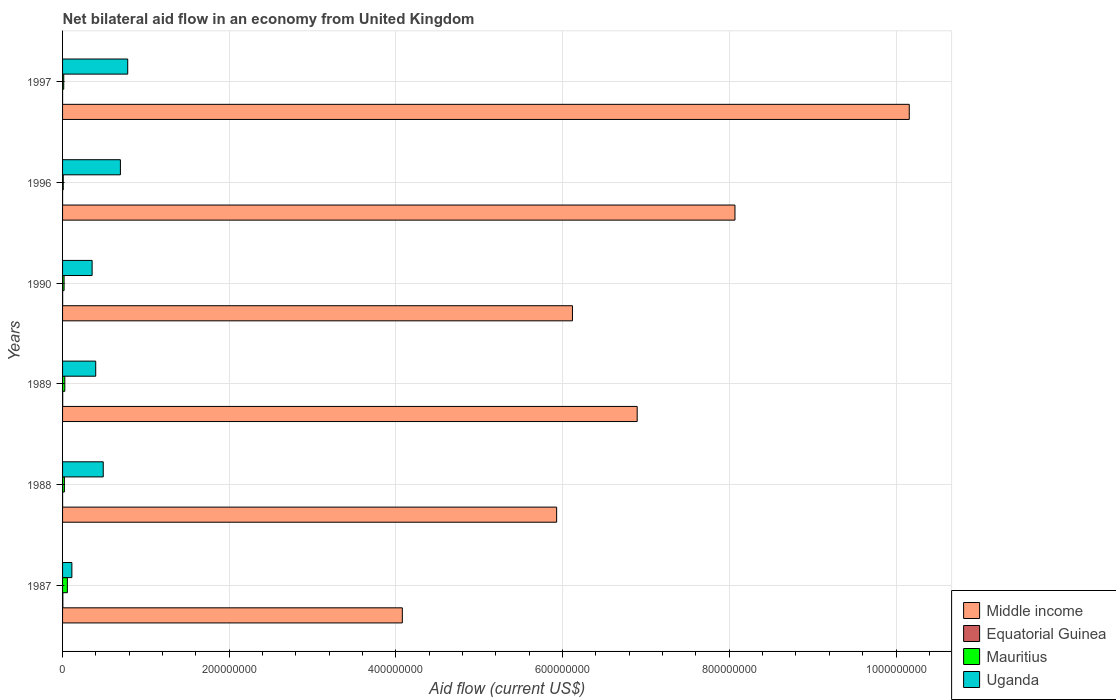How many different coloured bars are there?
Offer a terse response. 4. Are the number of bars per tick equal to the number of legend labels?
Your answer should be very brief. Yes. How many bars are there on the 1st tick from the top?
Keep it short and to the point. 4. How many bars are there on the 6th tick from the bottom?
Ensure brevity in your answer.  4. What is the label of the 6th group of bars from the top?
Ensure brevity in your answer.  1987. What is the net bilateral aid flow in Uganda in 1997?
Make the answer very short. 7.82e+07. Across all years, what is the maximum net bilateral aid flow in Equatorial Guinea?
Provide a succinct answer. 3.40e+05. Across all years, what is the minimum net bilateral aid flow in Equatorial Guinea?
Your answer should be very brief. 10000. In which year was the net bilateral aid flow in Equatorial Guinea minimum?
Your answer should be compact. 1997. What is the total net bilateral aid flow in Equatorial Guinea in the graph?
Offer a terse response. 6.30e+05. What is the difference between the net bilateral aid flow in Uganda in 1988 and that in 1997?
Provide a succinct answer. -2.94e+07. What is the difference between the net bilateral aid flow in Middle income in 1990 and the net bilateral aid flow in Mauritius in 1997?
Offer a terse response. 6.10e+08. What is the average net bilateral aid flow in Equatorial Guinea per year?
Your answer should be very brief. 1.05e+05. In the year 1996, what is the difference between the net bilateral aid flow in Uganda and net bilateral aid flow in Mauritius?
Offer a very short reply. 6.86e+07. In how many years, is the net bilateral aid flow in Uganda greater than 200000000 US$?
Your answer should be very brief. 0. What is the ratio of the net bilateral aid flow in Equatorial Guinea in 1987 to that in 1988?
Make the answer very short. 11.33. Is the difference between the net bilateral aid flow in Uganda in 1987 and 1996 greater than the difference between the net bilateral aid flow in Mauritius in 1987 and 1996?
Offer a very short reply. No. What is the difference between the highest and the lowest net bilateral aid flow in Uganda?
Offer a very short reply. 6.70e+07. In how many years, is the net bilateral aid flow in Mauritius greater than the average net bilateral aid flow in Mauritius taken over all years?
Give a very brief answer. 2. Is the sum of the net bilateral aid flow in Middle income in 1988 and 1997 greater than the maximum net bilateral aid flow in Mauritius across all years?
Ensure brevity in your answer.  Yes. Is it the case that in every year, the sum of the net bilateral aid flow in Equatorial Guinea and net bilateral aid flow in Uganda is greater than the sum of net bilateral aid flow in Middle income and net bilateral aid flow in Mauritius?
Provide a short and direct response. Yes. What does the 4th bar from the top in 1988 represents?
Provide a succinct answer. Middle income. What does the 3rd bar from the bottom in 1987 represents?
Offer a terse response. Mauritius. Is it the case that in every year, the sum of the net bilateral aid flow in Equatorial Guinea and net bilateral aid flow in Mauritius is greater than the net bilateral aid flow in Middle income?
Ensure brevity in your answer.  No. How many bars are there?
Make the answer very short. 24. Does the graph contain any zero values?
Provide a short and direct response. No. Does the graph contain grids?
Provide a succinct answer. Yes. Where does the legend appear in the graph?
Provide a short and direct response. Bottom right. How are the legend labels stacked?
Keep it short and to the point. Vertical. What is the title of the graph?
Keep it short and to the point. Net bilateral aid flow in an economy from United Kingdom. Does "Mauritius" appear as one of the legend labels in the graph?
Give a very brief answer. Yes. What is the label or title of the X-axis?
Make the answer very short. Aid flow (current US$). What is the label or title of the Y-axis?
Ensure brevity in your answer.  Years. What is the Aid flow (current US$) of Middle income in 1987?
Provide a succinct answer. 4.08e+08. What is the Aid flow (current US$) of Equatorial Guinea in 1987?
Keep it short and to the point. 3.40e+05. What is the Aid flow (current US$) of Mauritius in 1987?
Offer a very short reply. 5.77e+06. What is the Aid flow (current US$) of Uganda in 1987?
Your answer should be very brief. 1.12e+07. What is the Aid flow (current US$) of Middle income in 1988?
Offer a very short reply. 5.93e+08. What is the Aid flow (current US$) of Mauritius in 1988?
Make the answer very short. 2.18e+06. What is the Aid flow (current US$) in Uganda in 1988?
Ensure brevity in your answer.  4.88e+07. What is the Aid flow (current US$) of Middle income in 1989?
Ensure brevity in your answer.  6.89e+08. What is the Aid flow (current US$) of Equatorial Guinea in 1989?
Offer a terse response. 1.40e+05. What is the Aid flow (current US$) of Mauritius in 1989?
Keep it short and to the point. 2.70e+06. What is the Aid flow (current US$) of Uganda in 1989?
Your response must be concise. 3.98e+07. What is the Aid flow (current US$) in Middle income in 1990?
Your answer should be very brief. 6.12e+08. What is the Aid flow (current US$) in Equatorial Guinea in 1990?
Ensure brevity in your answer.  9.00e+04. What is the Aid flow (current US$) of Mauritius in 1990?
Offer a terse response. 1.82e+06. What is the Aid flow (current US$) of Uganda in 1990?
Keep it short and to the point. 3.54e+07. What is the Aid flow (current US$) of Middle income in 1996?
Ensure brevity in your answer.  8.07e+08. What is the Aid flow (current US$) in Equatorial Guinea in 1996?
Provide a short and direct response. 2.00e+04. What is the Aid flow (current US$) of Mauritius in 1996?
Your response must be concise. 8.30e+05. What is the Aid flow (current US$) of Uganda in 1996?
Keep it short and to the point. 6.94e+07. What is the Aid flow (current US$) of Middle income in 1997?
Your answer should be compact. 1.02e+09. What is the Aid flow (current US$) in Mauritius in 1997?
Offer a very short reply. 1.41e+06. What is the Aid flow (current US$) of Uganda in 1997?
Offer a terse response. 7.82e+07. Across all years, what is the maximum Aid flow (current US$) in Middle income?
Offer a terse response. 1.02e+09. Across all years, what is the maximum Aid flow (current US$) in Equatorial Guinea?
Ensure brevity in your answer.  3.40e+05. Across all years, what is the maximum Aid flow (current US$) of Mauritius?
Make the answer very short. 5.77e+06. Across all years, what is the maximum Aid flow (current US$) in Uganda?
Keep it short and to the point. 7.82e+07. Across all years, what is the minimum Aid flow (current US$) of Middle income?
Your answer should be very brief. 4.08e+08. Across all years, what is the minimum Aid flow (current US$) of Mauritius?
Your answer should be very brief. 8.30e+05. Across all years, what is the minimum Aid flow (current US$) in Uganda?
Keep it short and to the point. 1.12e+07. What is the total Aid flow (current US$) of Middle income in the graph?
Ensure brevity in your answer.  4.12e+09. What is the total Aid flow (current US$) in Equatorial Guinea in the graph?
Your response must be concise. 6.30e+05. What is the total Aid flow (current US$) in Mauritius in the graph?
Give a very brief answer. 1.47e+07. What is the total Aid flow (current US$) in Uganda in the graph?
Your answer should be very brief. 2.83e+08. What is the difference between the Aid flow (current US$) in Middle income in 1987 and that in 1988?
Ensure brevity in your answer.  -1.85e+08. What is the difference between the Aid flow (current US$) in Equatorial Guinea in 1987 and that in 1988?
Your response must be concise. 3.10e+05. What is the difference between the Aid flow (current US$) of Mauritius in 1987 and that in 1988?
Offer a very short reply. 3.59e+06. What is the difference between the Aid flow (current US$) of Uganda in 1987 and that in 1988?
Provide a succinct answer. -3.76e+07. What is the difference between the Aid flow (current US$) in Middle income in 1987 and that in 1989?
Offer a very short reply. -2.82e+08. What is the difference between the Aid flow (current US$) in Mauritius in 1987 and that in 1989?
Your answer should be very brief. 3.07e+06. What is the difference between the Aid flow (current US$) of Uganda in 1987 and that in 1989?
Offer a terse response. -2.86e+07. What is the difference between the Aid flow (current US$) of Middle income in 1987 and that in 1990?
Give a very brief answer. -2.04e+08. What is the difference between the Aid flow (current US$) of Mauritius in 1987 and that in 1990?
Provide a succinct answer. 3.95e+06. What is the difference between the Aid flow (current US$) of Uganda in 1987 and that in 1990?
Keep it short and to the point. -2.43e+07. What is the difference between the Aid flow (current US$) of Middle income in 1987 and that in 1996?
Provide a succinct answer. -3.99e+08. What is the difference between the Aid flow (current US$) in Mauritius in 1987 and that in 1996?
Provide a short and direct response. 4.94e+06. What is the difference between the Aid flow (current US$) in Uganda in 1987 and that in 1996?
Give a very brief answer. -5.82e+07. What is the difference between the Aid flow (current US$) in Middle income in 1987 and that in 1997?
Keep it short and to the point. -6.08e+08. What is the difference between the Aid flow (current US$) of Mauritius in 1987 and that in 1997?
Offer a terse response. 4.36e+06. What is the difference between the Aid flow (current US$) of Uganda in 1987 and that in 1997?
Your answer should be compact. -6.70e+07. What is the difference between the Aid flow (current US$) of Middle income in 1988 and that in 1989?
Ensure brevity in your answer.  -9.66e+07. What is the difference between the Aid flow (current US$) in Equatorial Guinea in 1988 and that in 1989?
Offer a very short reply. -1.10e+05. What is the difference between the Aid flow (current US$) in Mauritius in 1988 and that in 1989?
Keep it short and to the point. -5.20e+05. What is the difference between the Aid flow (current US$) in Uganda in 1988 and that in 1989?
Ensure brevity in your answer.  9.03e+06. What is the difference between the Aid flow (current US$) in Middle income in 1988 and that in 1990?
Give a very brief answer. -1.90e+07. What is the difference between the Aid flow (current US$) of Equatorial Guinea in 1988 and that in 1990?
Your response must be concise. -6.00e+04. What is the difference between the Aid flow (current US$) of Uganda in 1988 and that in 1990?
Offer a terse response. 1.34e+07. What is the difference between the Aid flow (current US$) in Middle income in 1988 and that in 1996?
Your answer should be very brief. -2.14e+08. What is the difference between the Aid flow (current US$) of Equatorial Guinea in 1988 and that in 1996?
Provide a succinct answer. 10000. What is the difference between the Aid flow (current US$) in Mauritius in 1988 and that in 1996?
Give a very brief answer. 1.35e+06. What is the difference between the Aid flow (current US$) in Uganda in 1988 and that in 1996?
Give a very brief answer. -2.06e+07. What is the difference between the Aid flow (current US$) in Middle income in 1988 and that in 1997?
Provide a short and direct response. -4.23e+08. What is the difference between the Aid flow (current US$) in Mauritius in 1988 and that in 1997?
Provide a succinct answer. 7.70e+05. What is the difference between the Aid flow (current US$) of Uganda in 1988 and that in 1997?
Your response must be concise. -2.94e+07. What is the difference between the Aid flow (current US$) in Middle income in 1989 and that in 1990?
Your response must be concise. 7.77e+07. What is the difference between the Aid flow (current US$) of Mauritius in 1989 and that in 1990?
Ensure brevity in your answer.  8.80e+05. What is the difference between the Aid flow (current US$) of Uganda in 1989 and that in 1990?
Ensure brevity in your answer.  4.32e+06. What is the difference between the Aid flow (current US$) of Middle income in 1989 and that in 1996?
Offer a terse response. -1.17e+08. What is the difference between the Aid flow (current US$) in Mauritius in 1989 and that in 1996?
Offer a terse response. 1.87e+06. What is the difference between the Aid flow (current US$) in Uganda in 1989 and that in 1996?
Give a very brief answer. -2.96e+07. What is the difference between the Aid flow (current US$) in Middle income in 1989 and that in 1997?
Ensure brevity in your answer.  -3.26e+08. What is the difference between the Aid flow (current US$) in Mauritius in 1989 and that in 1997?
Your response must be concise. 1.29e+06. What is the difference between the Aid flow (current US$) in Uganda in 1989 and that in 1997?
Make the answer very short. -3.84e+07. What is the difference between the Aid flow (current US$) in Middle income in 1990 and that in 1996?
Offer a terse response. -1.95e+08. What is the difference between the Aid flow (current US$) in Equatorial Guinea in 1990 and that in 1996?
Ensure brevity in your answer.  7.00e+04. What is the difference between the Aid flow (current US$) in Mauritius in 1990 and that in 1996?
Offer a terse response. 9.90e+05. What is the difference between the Aid flow (current US$) in Uganda in 1990 and that in 1996?
Give a very brief answer. -3.40e+07. What is the difference between the Aid flow (current US$) of Middle income in 1990 and that in 1997?
Your answer should be very brief. -4.04e+08. What is the difference between the Aid flow (current US$) of Equatorial Guinea in 1990 and that in 1997?
Give a very brief answer. 8.00e+04. What is the difference between the Aid flow (current US$) of Mauritius in 1990 and that in 1997?
Give a very brief answer. 4.10e+05. What is the difference between the Aid flow (current US$) of Uganda in 1990 and that in 1997?
Your answer should be compact. -4.27e+07. What is the difference between the Aid flow (current US$) in Middle income in 1996 and that in 1997?
Give a very brief answer. -2.09e+08. What is the difference between the Aid flow (current US$) in Mauritius in 1996 and that in 1997?
Keep it short and to the point. -5.80e+05. What is the difference between the Aid flow (current US$) of Uganda in 1996 and that in 1997?
Provide a short and direct response. -8.78e+06. What is the difference between the Aid flow (current US$) in Middle income in 1987 and the Aid flow (current US$) in Equatorial Guinea in 1988?
Provide a succinct answer. 4.08e+08. What is the difference between the Aid flow (current US$) of Middle income in 1987 and the Aid flow (current US$) of Mauritius in 1988?
Your answer should be compact. 4.05e+08. What is the difference between the Aid flow (current US$) in Middle income in 1987 and the Aid flow (current US$) in Uganda in 1988?
Give a very brief answer. 3.59e+08. What is the difference between the Aid flow (current US$) of Equatorial Guinea in 1987 and the Aid flow (current US$) of Mauritius in 1988?
Make the answer very short. -1.84e+06. What is the difference between the Aid flow (current US$) in Equatorial Guinea in 1987 and the Aid flow (current US$) in Uganda in 1988?
Provide a succinct answer. -4.85e+07. What is the difference between the Aid flow (current US$) in Mauritius in 1987 and the Aid flow (current US$) in Uganda in 1988?
Give a very brief answer. -4.30e+07. What is the difference between the Aid flow (current US$) in Middle income in 1987 and the Aid flow (current US$) in Equatorial Guinea in 1989?
Provide a succinct answer. 4.08e+08. What is the difference between the Aid flow (current US$) of Middle income in 1987 and the Aid flow (current US$) of Mauritius in 1989?
Provide a short and direct response. 4.05e+08. What is the difference between the Aid flow (current US$) of Middle income in 1987 and the Aid flow (current US$) of Uganda in 1989?
Make the answer very short. 3.68e+08. What is the difference between the Aid flow (current US$) in Equatorial Guinea in 1987 and the Aid flow (current US$) in Mauritius in 1989?
Offer a very short reply. -2.36e+06. What is the difference between the Aid flow (current US$) in Equatorial Guinea in 1987 and the Aid flow (current US$) in Uganda in 1989?
Provide a short and direct response. -3.94e+07. What is the difference between the Aid flow (current US$) in Mauritius in 1987 and the Aid flow (current US$) in Uganda in 1989?
Offer a very short reply. -3.40e+07. What is the difference between the Aid flow (current US$) in Middle income in 1987 and the Aid flow (current US$) in Equatorial Guinea in 1990?
Your response must be concise. 4.08e+08. What is the difference between the Aid flow (current US$) in Middle income in 1987 and the Aid flow (current US$) in Mauritius in 1990?
Offer a terse response. 4.06e+08. What is the difference between the Aid flow (current US$) in Middle income in 1987 and the Aid flow (current US$) in Uganda in 1990?
Offer a very short reply. 3.72e+08. What is the difference between the Aid flow (current US$) in Equatorial Guinea in 1987 and the Aid flow (current US$) in Mauritius in 1990?
Your response must be concise. -1.48e+06. What is the difference between the Aid flow (current US$) in Equatorial Guinea in 1987 and the Aid flow (current US$) in Uganda in 1990?
Your answer should be compact. -3.51e+07. What is the difference between the Aid flow (current US$) in Mauritius in 1987 and the Aid flow (current US$) in Uganda in 1990?
Keep it short and to the point. -2.97e+07. What is the difference between the Aid flow (current US$) of Middle income in 1987 and the Aid flow (current US$) of Equatorial Guinea in 1996?
Offer a very short reply. 4.08e+08. What is the difference between the Aid flow (current US$) in Middle income in 1987 and the Aid flow (current US$) in Mauritius in 1996?
Make the answer very short. 4.07e+08. What is the difference between the Aid flow (current US$) in Middle income in 1987 and the Aid flow (current US$) in Uganda in 1996?
Keep it short and to the point. 3.38e+08. What is the difference between the Aid flow (current US$) in Equatorial Guinea in 1987 and the Aid flow (current US$) in Mauritius in 1996?
Keep it short and to the point. -4.90e+05. What is the difference between the Aid flow (current US$) of Equatorial Guinea in 1987 and the Aid flow (current US$) of Uganda in 1996?
Ensure brevity in your answer.  -6.91e+07. What is the difference between the Aid flow (current US$) of Mauritius in 1987 and the Aid flow (current US$) of Uganda in 1996?
Ensure brevity in your answer.  -6.36e+07. What is the difference between the Aid flow (current US$) in Middle income in 1987 and the Aid flow (current US$) in Equatorial Guinea in 1997?
Provide a succinct answer. 4.08e+08. What is the difference between the Aid flow (current US$) in Middle income in 1987 and the Aid flow (current US$) in Mauritius in 1997?
Keep it short and to the point. 4.06e+08. What is the difference between the Aid flow (current US$) in Middle income in 1987 and the Aid flow (current US$) in Uganda in 1997?
Your answer should be very brief. 3.29e+08. What is the difference between the Aid flow (current US$) of Equatorial Guinea in 1987 and the Aid flow (current US$) of Mauritius in 1997?
Your answer should be compact. -1.07e+06. What is the difference between the Aid flow (current US$) in Equatorial Guinea in 1987 and the Aid flow (current US$) in Uganda in 1997?
Your answer should be very brief. -7.78e+07. What is the difference between the Aid flow (current US$) in Mauritius in 1987 and the Aid flow (current US$) in Uganda in 1997?
Offer a terse response. -7.24e+07. What is the difference between the Aid flow (current US$) in Middle income in 1988 and the Aid flow (current US$) in Equatorial Guinea in 1989?
Give a very brief answer. 5.93e+08. What is the difference between the Aid flow (current US$) in Middle income in 1988 and the Aid flow (current US$) in Mauritius in 1989?
Provide a short and direct response. 5.90e+08. What is the difference between the Aid flow (current US$) of Middle income in 1988 and the Aid flow (current US$) of Uganda in 1989?
Keep it short and to the point. 5.53e+08. What is the difference between the Aid flow (current US$) of Equatorial Guinea in 1988 and the Aid flow (current US$) of Mauritius in 1989?
Offer a very short reply. -2.67e+06. What is the difference between the Aid flow (current US$) in Equatorial Guinea in 1988 and the Aid flow (current US$) in Uganda in 1989?
Ensure brevity in your answer.  -3.97e+07. What is the difference between the Aid flow (current US$) in Mauritius in 1988 and the Aid flow (current US$) in Uganda in 1989?
Give a very brief answer. -3.76e+07. What is the difference between the Aid flow (current US$) of Middle income in 1988 and the Aid flow (current US$) of Equatorial Guinea in 1990?
Ensure brevity in your answer.  5.93e+08. What is the difference between the Aid flow (current US$) in Middle income in 1988 and the Aid flow (current US$) in Mauritius in 1990?
Offer a terse response. 5.91e+08. What is the difference between the Aid flow (current US$) of Middle income in 1988 and the Aid flow (current US$) of Uganda in 1990?
Keep it short and to the point. 5.57e+08. What is the difference between the Aid flow (current US$) of Equatorial Guinea in 1988 and the Aid flow (current US$) of Mauritius in 1990?
Provide a short and direct response. -1.79e+06. What is the difference between the Aid flow (current US$) of Equatorial Guinea in 1988 and the Aid flow (current US$) of Uganda in 1990?
Offer a terse response. -3.54e+07. What is the difference between the Aid flow (current US$) in Mauritius in 1988 and the Aid flow (current US$) in Uganda in 1990?
Make the answer very short. -3.33e+07. What is the difference between the Aid flow (current US$) of Middle income in 1988 and the Aid flow (current US$) of Equatorial Guinea in 1996?
Your answer should be very brief. 5.93e+08. What is the difference between the Aid flow (current US$) in Middle income in 1988 and the Aid flow (current US$) in Mauritius in 1996?
Give a very brief answer. 5.92e+08. What is the difference between the Aid flow (current US$) of Middle income in 1988 and the Aid flow (current US$) of Uganda in 1996?
Give a very brief answer. 5.23e+08. What is the difference between the Aid flow (current US$) of Equatorial Guinea in 1988 and the Aid flow (current US$) of Mauritius in 1996?
Ensure brevity in your answer.  -8.00e+05. What is the difference between the Aid flow (current US$) in Equatorial Guinea in 1988 and the Aid flow (current US$) in Uganda in 1996?
Offer a terse response. -6.94e+07. What is the difference between the Aid flow (current US$) of Mauritius in 1988 and the Aid flow (current US$) of Uganda in 1996?
Offer a very short reply. -6.72e+07. What is the difference between the Aid flow (current US$) in Middle income in 1988 and the Aid flow (current US$) in Equatorial Guinea in 1997?
Provide a short and direct response. 5.93e+08. What is the difference between the Aid flow (current US$) of Middle income in 1988 and the Aid flow (current US$) of Mauritius in 1997?
Give a very brief answer. 5.91e+08. What is the difference between the Aid flow (current US$) in Middle income in 1988 and the Aid flow (current US$) in Uganda in 1997?
Your answer should be very brief. 5.15e+08. What is the difference between the Aid flow (current US$) of Equatorial Guinea in 1988 and the Aid flow (current US$) of Mauritius in 1997?
Ensure brevity in your answer.  -1.38e+06. What is the difference between the Aid flow (current US$) of Equatorial Guinea in 1988 and the Aid flow (current US$) of Uganda in 1997?
Give a very brief answer. -7.82e+07. What is the difference between the Aid flow (current US$) of Mauritius in 1988 and the Aid flow (current US$) of Uganda in 1997?
Provide a short and direct response. -7.60e+07. What is the difference between the Aid flow (current US$) of Middle income in 1989 and the Aid flow (current US$) of Equatorial Guinea in 1990?
Keep it short and to the point. 6.89e+08. What is the difference between the Aid flow (current US$) of Middle income in 1989 and the Aid flow (current US$) of Mauritius in 1990?
Keep it short and to the point. 6.88e+08. What is the difference between the Aid flow (current US$) of Middle income in 1989 and the Aid flow (current US$) of Uganda in 1990?
Provide a succinct answer. 6.54e+08. What is the difference between the Aid flow (current US$) of Equatorial Guinea in 1989 and the Aid flow (current US$) of Mauritius in 1990?
Give a very brief answer. -1.68e+06. What is the difference between the Aid flow (current US$) of Equatorial Guinea in 1989 and the Aid flow (current US$) of Uganda in 1990?
Provide a short and direct response. -3.53e+07. What is the difference between the Aid flow (current US$) of Mauritius in 1989 and the Aid flow (current US$) of Uganda in 1990?
Your response must be concise. -3.28e+07. What is the difference between the Aid flow (current US$) in Middle income in 1989 and the Aid flow (current US$) in Equatorial Guinea in 1996?
Provide a short and direct response. 6.89e+08. What is the difference between the Aid flow (current US$) in Middle income in 1989 and the Aid flow (current US$) in Mauritius in 1996?
Make the answer very short. 6.89e+08. What is the difference between the Aid flow (current US$) of Middle income in 1989 and the Aid flow (current US$) of Uganda in 1996?
Provide a succinct answer. 6.20e+08. What is the difference between the Aid flow (current US$) in Equatorial Guinea in 1989 and the Aid flow (current US$) in Mauritius in 1996?
Your response must be concise. -6.90e+05. What is the difference between the Aid flow (current US$) of Equatorial Guinea in 1989 and the Aid flow (current US$) of Uganda in 1996?
Provide a succinct answer. -6.93e+07. What is the difference between the Aid flow (current US$) in Mauritius in 1989 and the Aid flow (current US$) in Uganda in 1996?
Provide a short and direct response. -6.67e+07. What is the difference between the Aid flow (current US$) of Middle income in 1989 and the Aid flow (current US$) of Equatorial Guinea in 1997?
Offer a terse response. 6.89e+08. What is the difference between the Aid flow (current US$) of Middle income in 1989 and the Aid flow (current US$) of Mauritius in 1997?
Your answer should be very brief. 6.88e+08. What is the difference between the Aid flow (current US$) of Middle income in 1989 and the Aid flow (current US$) of Uganda in 1997?
Keep it short and to the point. 6.11e+08. What is the difference between the Aid flow (current US$) of Equatorial Guinea in 1989 and the Aid flow (current US$) of Mauritius in 1997?
Offer a terse response. -1.27e+06. What is the difference between the Aid flow (current US$) in Equatorial Guinea in 1989 and the Aid flow (current US$) in Uganda in 1997?
Keep it short and to the point. -7.80e+07. What is the difference between the Aid flow (current US$) of Mauritius in 1989 and the Aid flow (current US$) of Uganda in 1997?
Provide a succinct answer. -7.55e+07. What is the difference between the Aid flow (current US$) in Middle income in 1990 and the Aid flow (current US$) in Equatorial Guinea in 1996?
Your answer should be very brief. 6.12e+08. What is the difference between the Aid flow (current US$) in Middle income in 1990 and the Aid flow (current US$) in Mauritius in 1996?
Your response must be concise. 6.11e+08. What is the difference between the Aid flow (current US$) of Middle income in 1990 and the Aid flow (current US$) of Uganda in 1996?
Provide a succinct answer. 5.42e+08. What is the difference between the Aid flow (current US$) in Equatorial Guinea in 1990 and the Aid flow (current US$) in Mauritius in 1996?
Your answer should be compact. -7.40e+05. What is the difference between the Aid flow (current US$) of Equatorial Guinea in 1990 and the Aid flow (current US$) of Uganda in 1996?
Offer a very short reply. -6.93e+07. What is the difference between the Aid flow (current US$) of Mauritius in 1990 and the Aid flow (current US$) of Uganda in 1996?
Your answer should be compact. -6.76e+07. What is the difference between the Aid flow (current US$) in Middle income in 1990 and the Aid flow (current US$) in Equatorial Guinea in 1997?
Provide a short and direct response. 6.12e+08. What is the difference between the Aid flow (current US$) in Middle income in 1990 and the Aid flow (current US$) in Mauritius in 1997?
Your response must be concise. 6.10e+08. What is the difference between the Aid flow (current US$) in Middle income in 1990 and the Aid flow (current US$) in Uganda in 1997?
Offer a very short reply. 5.34e+08. What is the difference between the Aid flow (current US$) in Equatorial Guinea in 1990 and the Aid flow (current US$) in Mauritius in 1997?
Keep it short and to the point. -1.32e+06. What is the difference between the Aid flow (current US$) in Equatorial Guinea in 1990 and the Aid flow (current US$) in Uganda in 1997?
Your response must be concise. -7.81e+07. What is the difference between the Aid flow (current US$) in Mauritius in 1990 and the Aid flow (current US$) in Uganda in 1997?
Your answer should be very brief. -7.64e+07. What is the difference between the Aid flow (current US$) of Middle income in 1996 and the Aid flow (current US$) of Equatorial Guinea in 1997?
Give a very brief answer. 8.07e+08. What is the difference between the Aid flow (current US$) in Middle income in 1996 and the Aid flow (current US$) in Mauritius in 1997?
Offer a very short reply. 8.05e+08. What is the difference between the Aid flow (current US$) of Middle income in 1996 and the Aid flow (current US$) of Uganda in 1997?
Provide a succinct answer. 7.29e+08. What is the difference between the Aid flow (current US$) in Equatorial Guinea in 1996 and the Aid flow (current US$) in Mauritius in 1997?
Your answer should be very brief. -1.39e+06. What is the difference between the Aid flow (current US$) of Equatorial Guinea in 1996 and the Aid flow (current US$) of Uganda in 1997?
Offer a terse response. -7.82e+07. What is the difference between the Aid flow (current US$) of Mauritius in 1996 and the Aid flow (current US$) of Uganda in 1997?
Provide a succinct answer. -7.74e+07. What is the average Aid flow (current US$) of Middle income per year?
Keep it short and to the point. 6.87e+08. What is the average Aid flow (current US$) in Equatorial Guinea per year?
Offer a very short reply. 1.05e+05. What is the average Aid flow (current US$) in Mauritius per year?
Your response must be concise. 2.45e+06. What is the average Aid flow (current US$) in Uganda per year?
Offer a very short reply. 4.71e+07. In the year 1987, what is the difference between the Aid flow (current US$) of Middle income and Aid flow (current US$) of Equatorial Guinea?
Ensure brevity in your answer.  4.07e+08. In the year 1987, what is the difference between the Aid flow (current US$) of Middle income and Aid flow (current US$) of Mauritius?
Ensure brevity in your answer.  4.02e+08. In the year 1987, what is the difference between the Aid flow (current US$) of Middle income and Aid flow (current US$) of Uganda?
Give a very brief answer. 3.96e+08. In the year 1987, what is the difference between the Aid flow (current US$) in Equatorial Guinea and Aid flow (current US$) in Mauritius?
Your answer should be compact. -5.43e+06. In the year 1987, what is the difference between the Aid flow (current US$) of Equatorial Guinea and Aid flow (current US$) of Uganda?
Offer a terse response. -1.08e+07. In the year 1987, what is the difference between the Aid flow (current US$) of Mauritius and Aid flow (current US$) of Uganda?
Your answer should be compact. -5.40e+06. In the year 1988, what is the difference between the Aid flow (current US$) of Middle income and Aid flow (current US$) of Equatorial Guinea?
Offer a very short reply. 5.93e+08. In the year 1988, what is the difference between the Aid flow (current US$) of Middle income and Aid flow (current US$) of Mauritius?
Give a very brief answer. 5.91e+08. In the year 1988, what is the difference between the Aid flow (current US$) of Middle income and Aid flow (current US$) of Uganda?
Make the answer very short. 5.44e+08. In the year 1988, what is the difference between the Aid flow (current US$) in Equatorial Guinea and Aid flow (current US$) in Mauritius?
Offer a very short reply. -2.15e+06. In the year 1988, what is the difference between the Aid flow (current US$) in Equatorial Guinea and Aid flow (current US$) in Uganda?
Offer a very short reply. -4.88e+07. In the year 1988, what is the difference between the Aid flow (current US$) in Mauritius and Aid flow (current US$) in Uganda?
Ensure brevity in your answer.  -4.66e+07. In the year 1989, what is the difference between the Aid flow (current US$) in Middle income and Aid flow (current US$) in Equatorial Guinea?
Your answer should be compact. 6.89e+08. In the year 1989, what is the difference between the Aid flow (current US$) in Middle income and Aid flow (current US$) in Mauritius?
Ensure brevity in your answer.  6.87e+08. In the year 1989, what is the difference between the Aid flow (current US$) of Middle income and Aid flow (current US$) of Uganda?
Your answer should be very brief. 6.50e+08. In the year 1989, what is the difference between the Aid flow (current US$) of Equatorial Guinea and Aid flow (current US$) of Mauritius?
Ensure brevity in your answer.  -2.56e+06. In the year 1989, what is the difference between the Aid flow (current US$) of Equatorial Guinea and Aid flow (current US$) of Uganda?
Provide a succinct answer. -3.96e+07. In the year 1989, what is the difference between the Aid flow (current US$) of Mauritius and Aid flow (current US$) of Uganda?
Offer a terse response. -3.71e+07. In the year 1990, what is the difference between the Aid flow (current US$) in Middle income and Aid flow (current US$) in Equatorial Guinea?
Provide a succinct answer. 6.12e+08. In the year 1990, what is the difference between the Aid flow (current US$) in Middle income and Aid flow (current US$) in Mauritius?
Provide a short and direct response. 6.10e+08. In the year 1990, what is the difference between the Aid flow (current US$) in Middle income and Aid flow (current US$) in Uganda?
Provide a succinct answer. 5.76e+08. In the year 1990, what is the difference between the Aid flow (current US$) in Equatorial Guinea and Aid flow (current US$) in Mauritius?
Provide a short and direct response. -1.73e+06. In the year 1990, what is the difference between the Aid flow (current US$) of Equatorial Guinea and Aid flow (current US$) of Uganda?
Provide a succinct answer. -3.54e+07. In the year 1990, what is the difference between the Aid flow (current US$) in Mauritius and Aid flow (current US$) in Uganda?
Keep it short and to the point. -3.36e+07. In the year 1996, what is the difference between the Aid flow (current US$) in Middle income and Aid flow (current US$) in Equatorial Guinea?
Provide a short and direct response. 8.07e+08. In the year 1996, what is the difference between the Aid flow (current US$) of Middle income and Aid flow (current US$) of Mauritius?
Ensure brevity in your answer.  8.06e+08. In the year 1996, what is the difference between the Aid flow (current US$) of Middle income and Aid flow (current US$) of Uganda?
Provide a succinct answer. 7.37e+08. In the year 1996, what is the difference between the Aid flow (current US$) in Equatorial Guinea and Aid flow (current US$) in Mauritius?
Give a very brief answer. -8.10e+05. In the year 1996, what is the difference between the Aid flow (current US$) of Equatorial Guinea and Aid flow (current US$) of Uganda?
Give a very brief answer. -6.94e+07. In the year 1996, what is the difference between the Aid flow (current US$) in Mauritius and Aid flow (current US$) in Uganda?
Give a very brief answer. -6.86e+07. In the year 1997, what is the difference between the Aid flow (current US$) in Middle income and Aid flow (current US$) in Equatorial Guinea?
Offer a very short reply. 1.02e+09. In the year 1997, what is the difference between the Aid flow (current US$) in Middle income and Aid flow (current US$) in Mauritius?
Provide a succinct answer. 1.01e+09. In the year 1997, what is the difference between the Aid flow (current US$) of Middle income and Aid flow (current US$) of Uganda?
Your answer should be compact. 9.38e+08. In the year 1997, what is the difference between the Aid flow (current US$) in Equatorial Guinea and Aid flow (current US$) in Mauritius?
Offer a terse response. -1.40e+06. In the year 1997, what is the difference between the Aid flow (current US$) of Equatorial Guinea and Aid flow (current US$) of Uganda?
Your answer should be compact. -7.82e+07. In the year 1997, what is the difference between the Aid flow (current US$) in Mauritius and Aid flow (current US$) in Uganda?
Provide a short and direct response. -7.68e+07. What is the ratio of the Aid flow (current US$) of Middle income in 1987 to that in 1988?
Offer a very short reply. 0.69. What is the ratio of the Aid flow (current US$) in Equatorial Guinea in 1987 to that in 1988?
Provide a succinct answer. 11.33. What is the ratio of the Aid flow (current US$) of Mauritius in 1987 to that in 1988?
Offer a very short reply. 2.65. What is the ratio of the Aid flow (current US$) of Uganda in 1987 to that in 1988?
Ensure brevity in your answer.  0.23. What is the ratio of the Aid flow (current US$) of Middle income in 1987 to that in 1989?
Make the answer very short. 0.59. What is the ratio of the Aid flow (current US$) of Equatorial Guinea in 1987 to that in 1989?
Your answer should be compact. 2.43. What is the ratio of the Aid flow (current US$) in Mauritius in 1987 to that in 1989?
Your answer should be compact. 2.14. What is the ratio of the Aid flow (current US$) of Uganda in 1987 to that in 1989?
Offer a very short reply. 0.28. What is the ratio of the Aid flow (current US$) of Middle income in 1987 to that in 1990?
Your answer should be very brief. 0.67. What is the ratio of the Aid flow (current US$) of Equatorial Guinea in 1987 to that in 1990?
Provide a succinct answer. 3.78. What is the ratio of the Aid flow (current US$) of Mauritius in 1987 to that in 1990?
Offer a terse response. 3.17. What is the ratio of the Aid flow (current US$) in Uganda in 1987 to that in 1990?
Ensure brevity in your answer.  0.32. What is the ratio of the Aid flow (current US$) in Middle income in 1987 to that in 1996?
Make the answer very short. 0.51. What is the ratio of the Aid flow (current US$) of Mauritius in 1987 to that in 1996?
Provide a short and direct response. 6.95. What is the ratio of the Aid flow (current US$) in Uganda in 1987 to that in 1996?
Provide a succinct answer. 0.16. What is the ratio of the Aid flow (current US$) in Middle income in 1987 to that in 1997?
Provide a short and direct response. 0.4. What is the ratio of the Aid flow (current US$) of Mauritius in 1987 to that in 1997?
Your answer should be compact. 4.09. What is the ratio of the Aid flow (current US$) of Uganda in 1987 to that in 1997?
Make the answer very short. 0.14. What is the ratio of the Aid flow (current US$) in Middle income in 1988 to that in 1989?
Your response must be concise. 0.86. What is the ratio of the Aid flow (current US$) in Equatorial Guinea in 1988 to that in 1989?
Your answer should be very brief. 0.21. What is the ratio of the Aid flow (current US$) of Mauritius in 1988 to that in 1989?
Give a very brief answer. 0.81. What is the ratio of the Aid flow (current US$) of Uganda in 1988 to that in 1989?
Keep it short and to the point. 1.23. What is the ratio of the Aid flow (current US$) of Middle income in 1988 to that in 1990?
Keep it short and to the point. 0.97. What is the ratio of the Aid flow (current US$) in Equatorial Guinea in 1988 to that in 1990?
Your answer should be very brief. 0.33. What is the ratio of the Aid flow (current US$) of Mauritius in 1988 to that in 1990?
Provide a short and direct response. 1.2. What is the ratio of the Aid flow (current US$) in Uganda in 1988 to that in 1990?
Your response must be concise. 1.38. What is the ratio of the Aid flow (current US$) in Middle income in 1988 to that in 1996?
Your answer should be very brief. 0.73. What is the ratio of the Aid flow (current US$) of Mauritius in 1988 to that in 1996?
Offer a terse response. 2.63. What is the ratio of the Aid flow (current US$) of Uganda in 1988 to that in 1996?
Provide a short and direct response. 0.7. What is the ratio of the Aid flow (current US$) of Middle income in 1988 to that in 1997?
Give a very brief answer. 0.58. What is the ratio of the Aid flow (current US$) in Equatorial Guinea in 1988 to that in 1997?
Provide a short and direct response. 3. What is the ratio of the Aid flow (current US$) in Mauritius in 1988 to that in 1997?
Give a very brief answer. 1.55. What is the ratio of the Aid flow (current US$) of Uganda in 1988 to that in 1997?
Your answer should be very brief. 0.62. What is the ratio of the Aid flow (current US$) of Middle income in 1989 to that in 1990?
Ensure brevity in your answer.  1.13. What is the ratio of the Aid flow (current US$) in Equatorial Guinea in 1989 to that in 1990?
Your answer should be compact. 1.56. What is the ratio of the Aid flow (current US$) of Mauritius in 1989 to that in 1990?
Provide a short and direct response. 1.48. What is the ratio of the Aid flow (current US$) of Uganda in 1989 to that in 1990?
Your response must be concise. 1.12. What is the ratio of the Aid flow (current US$) in Middle income in 1989 to that in 1996?
Keep it short and to the point. 0.85. What is the ratio of the Aid flow (current US$) in Mauritius in 1989 to that in 1996?
Provide a short and direct response. 3.25. What is the ratio of the Aid flow (current US$) in Uganda in 1989 to that in 1996?
Offer a very short reply. 0.57. What is the ratio of the Aid flow (current US$) in Middle income in 1989 to that in 1997?
Keep it short and to the point. 0.68. What is the ratio of the Aid flow (current US$) of Equatorial Guinea in 1989 to that in 1997?
Keep it short and to the point. 14. What is the ratio of the Aid flow (current US$) of Mauritius in 1989 to that in 1997?
Offer a very short reply. 1.91. What is the ratio of the Aid flow (current US$) in Uganda in 1989 to that in 1997?
Your answer should be compact. 0.51. What is the ratio of the Aid flow (current US$) of Middle income in 1990 to that in 1996?
Provide a short and direct response. 0.76. What is the ratio of the Aid flow (current US$) in Equatorial Guinea in 1990 to that in 1996?
Your response must be concise. 4.5. What is the ratio of the Aid flow (current US$) of Mauritius in 1990 to that in 1996?
Provide a short and direct response. 2.19. What is the ratio of the Aid flow (current US$) in Uganda in 1990 to that in 1996?
Offer a terse response. 0.51. What is the ratio of the Aid flow (current US$) in Middle income in 1990 to that in 1997?
Give a very brief answer. 0.6. What is the ratio of the Aid flow (current US$) in Equatorial Guinea in 1990 to that in 1997?
Give a very brief answer. 9. What is the ratio of the Aid flow (current US$) in Mauritius in 1990 to that in 1997?
Offer a very short reply. 1.29. What is the ratio of the Aid flow (current US$) in Uganda in 1990 to that in 1997?
Keep it short and to the point. 0.45. What is the ratio of the Aid flow (current US$) in Middle income in 1996 to that in 1997?
Your answer should be compact. 0.79. What is the ratio of the Aid flow (current US$) of Equatorial Guinea in 1996 to that in 1997?
Your answer should be compact. 2. What is the ratio of the Aid flow (current US$) of Mauritius in 1996 to that in 1997?
Ensure brevity in your answer.  0.59. What is the ratio of the Aid flow (current US$) of Uganda in 1996 to that in 1997?
Your answer should be very brief. 0.89. What is the difference between the highest and the second highest Aid flow (current US$) in Middle income?
Your answer should be very brief. 2.09e+08. What is the difference between the highest and the second highest Aid flow (current US$) in Mauritius?
Offer a very short reply. 3.07e+06. What is the difference between the highest and the second highest Aid flow (current US$) in Uganda?
Provide a succinct answer. 8.78e+06. What is the difference between the highest and the lowest Aid flow (current US$) in Middle income?
Your response must be concise. 6.08e+08. What is the difference between the highest and the lowest Aid flow (current US$) of Equatorial Guinea?
Ensure brevity in your answer.  3.30e+05. What is the difference between the highest and the lowest Aid flow (current US$) of Mauritius?
Your answer should be very brief. 4.94e+06. What is the difference between the highest and the lowest Aid flow (current US$) of Uganda?
Ensure brevity in your answer.  6.70e+07. 